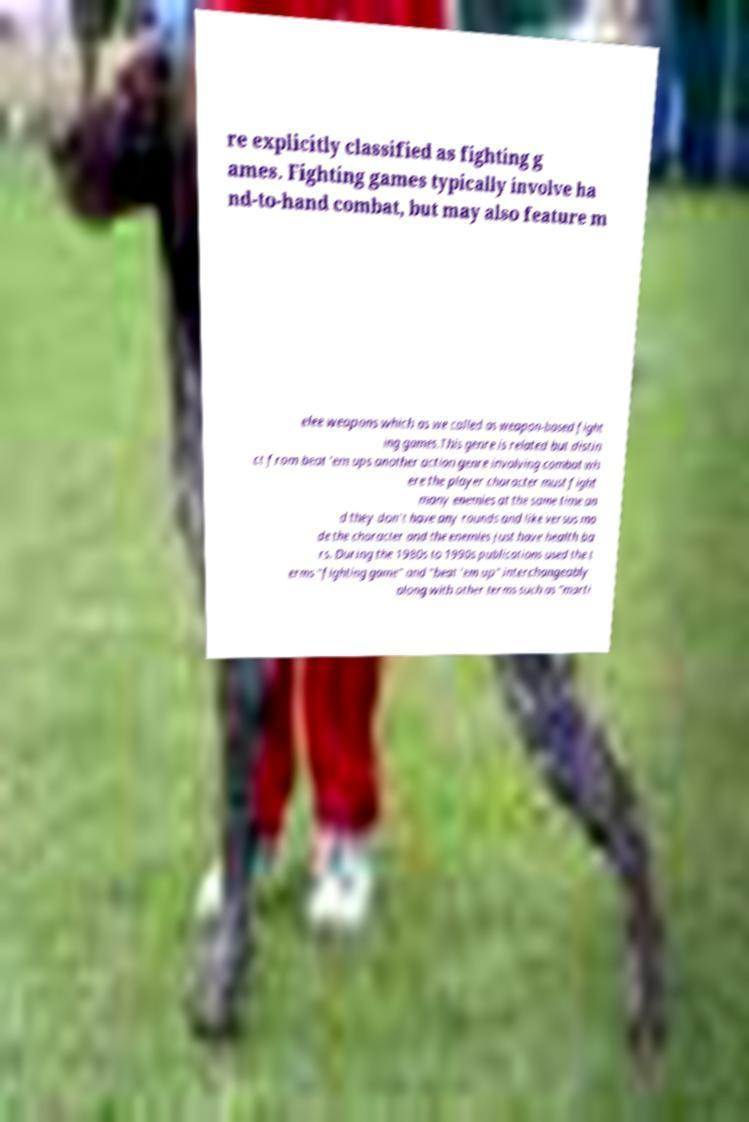Please read and relay the text visible in this image. What does it say? re explicitly classified as fighting g ames. Fighting games typically involve ha nd-to-hand combat, but may also feature m elee weapons which as we called as weapon-based fight ing games.This genre is related but distin ct from beat 'em ups another action genre involving combat wh ere the player character must fight many enemies at the same time an d they don't have any rounds and like versus mo de the character and the enemies just have health ba rs. During the 1980s to 1990s publications used the t erms "fighting game" and "beat 'em up" interchangeably along with other terms such as "marti 